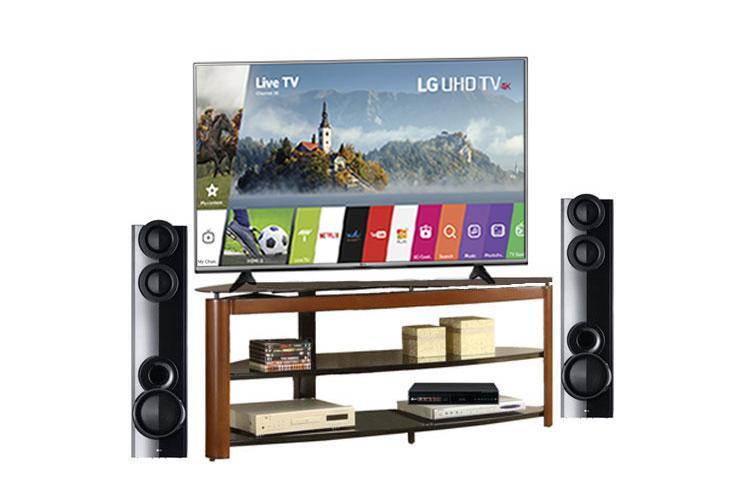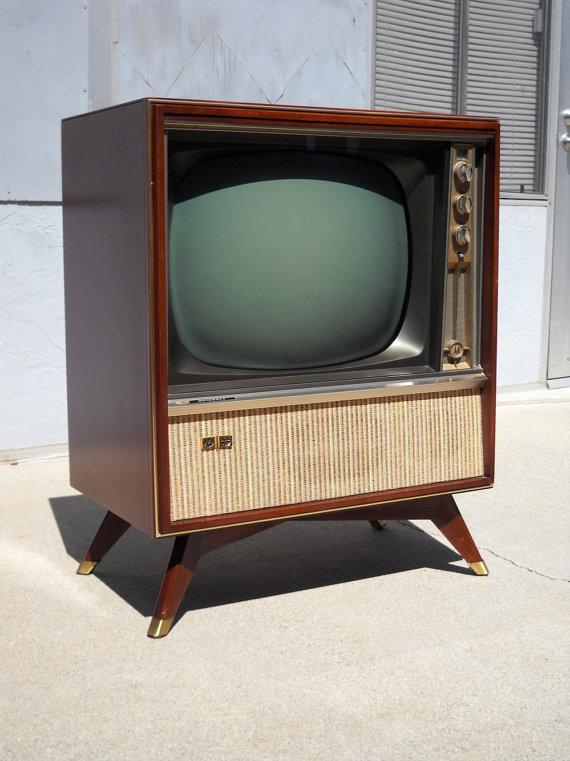The first image is the image on the left, the second image is the image on the right. Analyze the images presented: Is the assertion "All televisions are large tube screens in wooden cabinets." valid? Answer yes or no. No. 